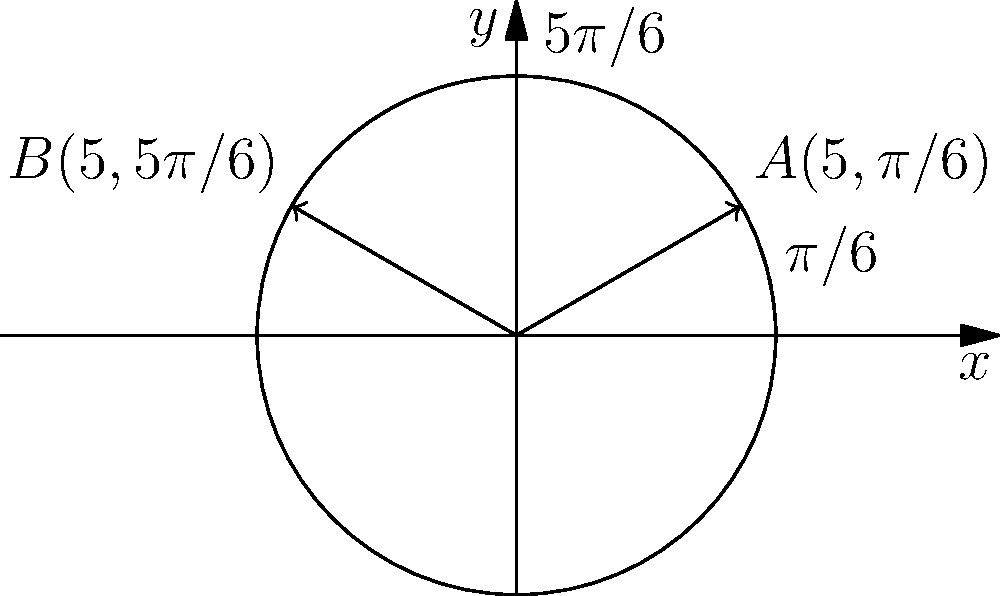Two potential locations for a community center are represented on a polar grid. Location A has coordinates $(5,\pi/6)$ and location B has coordinates $(5,5\pi/6)$. What is the distance between these two locations? To find the distance between two points in polar coordinates, we can use the following steps:

1) First, recall the formula for the distance $d$ between two points $(r_1,\theta_1)$ and $(r_2,\theta_2)$ in polar coordinates:

   $$d = \sqrt{r_1^2 + r_2^2 - 2r_1r_2\cos(\theta_2 - \theta_1)}$$

2) In this case, we have:
   $r_1 = r_2 = 5$
   $\theta_1 = \pi/6$
   $\theta_2 = 5\pi/6$

3) Let's substitute these values into the formula:

   $$d = \sqrt{5^2 + 5^2 - 2(5)(5)\cos(5\pi/6 - \pi/6)}$$

4) Simplify inside the parentheses:

   $$d = \sqrt{25 + 25 - 50\cos(2\pi/3)}$$

5) Recall that $\cos(2\pi/3) = -1/2$:

   $$d = \sqrt{50 + 50(-1/2)}$$

6) Simplify:

   $$d = \sqrt{50 - 25} = \sqrt{25} = 5$$

Therefore, the distance between the two locations is 5 units.
Answer: 5 units 